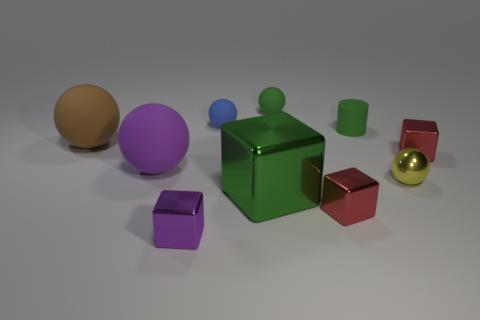There is a block that is the same color as the rubber cylinder; what is it made of?
Offer a terse response. Metal. Are there more large balls to the right of the brown matte sphere than blue matte balls in front of the tiny green cylinder?
Your answer should be very brief. Yes. What number of tiny red objects are the same shape as the large brown matte object?
Your answer should be compact. 0. How many objects are either small red things that are behind the tiny yellow metallic sphere or brown balls left of the blue matte object?
Make the answer very short. 2. What material is the green object in front of the large sphere that is behind the purple thing to the left of the tiny purple cube?
Give a very brief answer. Metal. There is a large object that is right of the purple rubber object; is it the same color as the cylinder?
Your answer should be very brief. Yes. There is a ball that is in front of the tiny green matte ball and behind the brown matte thing; what is its material?
Offer a terse response. Rubber. Is there a brown rubber sphere that has the same size as the matte cylinder?
Offer a very short reply. No. How many blue spheres are there?
Offer a very short reply. 1. How many purple metal blocks are in front of the blue sphere?
Make the answer very short. 1. 